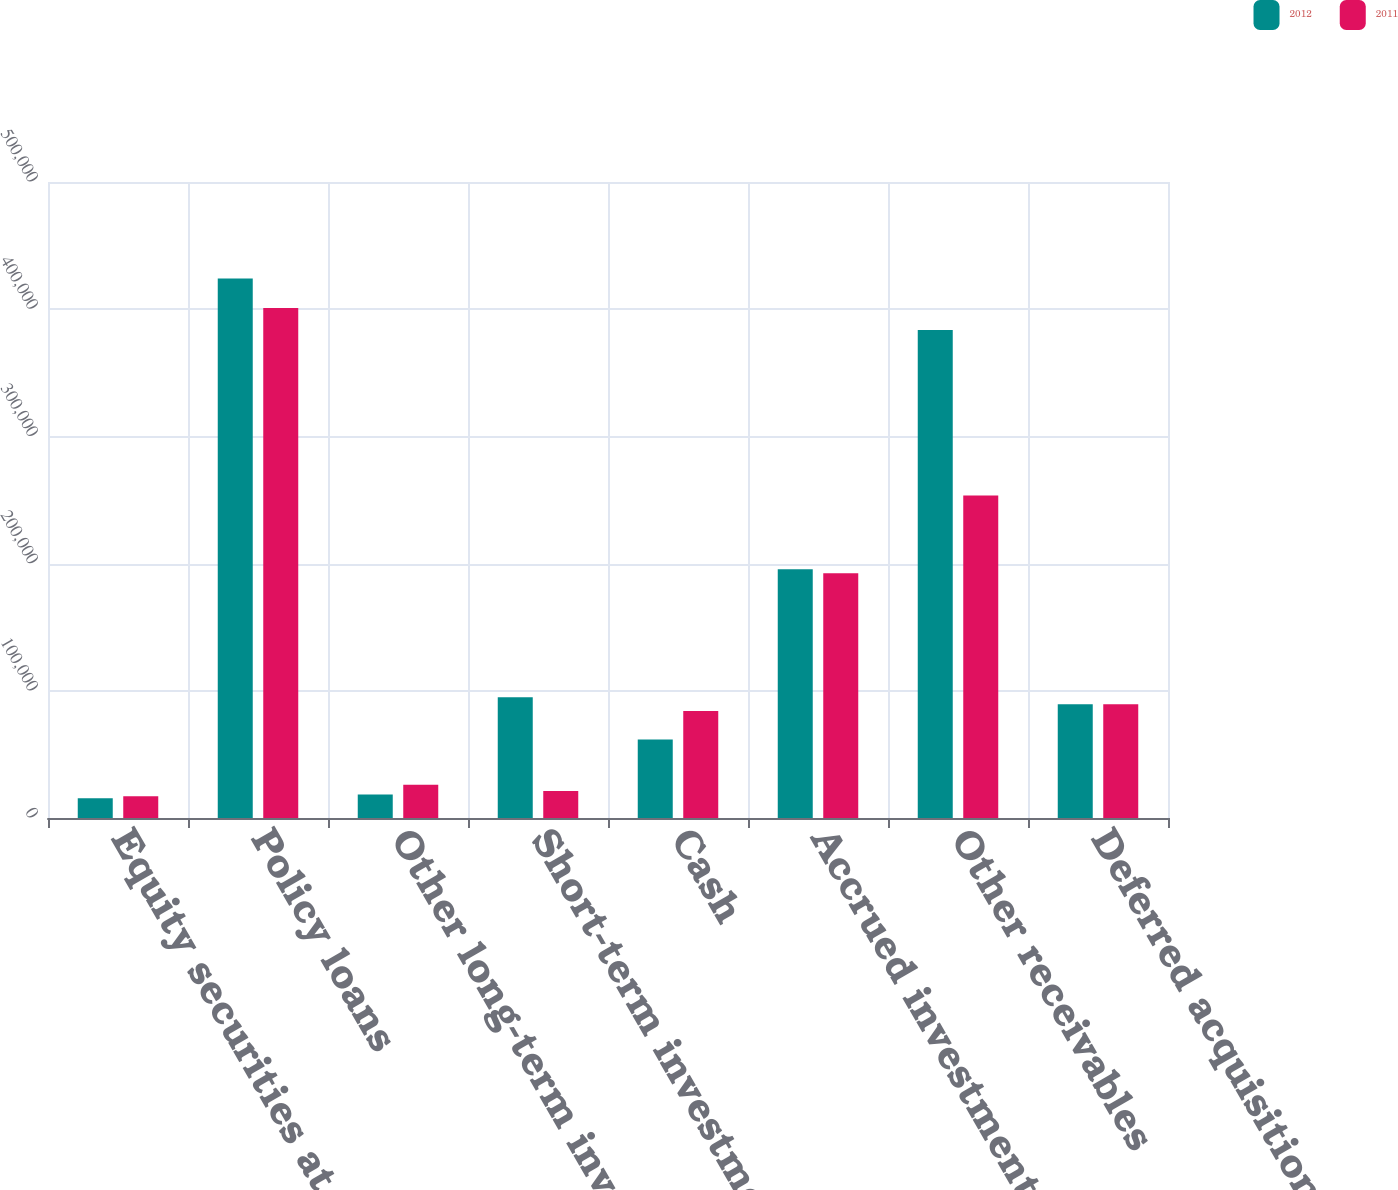<chart> <loc_0><loc_0><loc_500><loc_500><stacked_bar_chart><ecel><fcel>Equity securities at fair<fcel>Policy loans<fcel>Other long-term investments<fcel>Short-term investments<fcel>Cash<fcel>Accrued investment income<fcel>Other receivables<fcel>Deferred acquisition costs<nl><fcel>2012<fcel>15567<fcel>424050<fcel>18539<fcel>94860<fcel>61710<fcel>195497<fcel>383709<fcel>89486.5<nl><fcel>2011<fcel>17056<fcel>400914<fcel>26167<fcel>21244<fcel>84113<fcel>192325<fcel>253549<fcel>89486.5<nl></chart> 